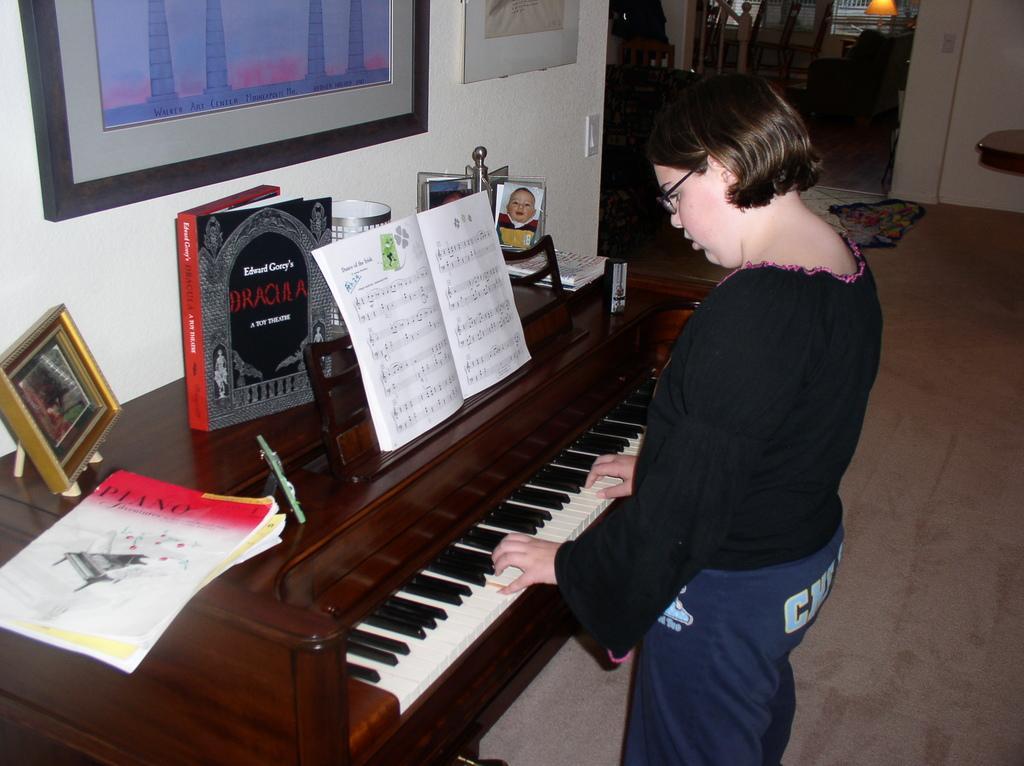How would you summarize this image in a sentence or two? In this picture there is a woman standing and playing a piano. There is a book, a frame, few frames and a container on the desk. There is a frame on the wall. There is a lamp and sofa at the background. 